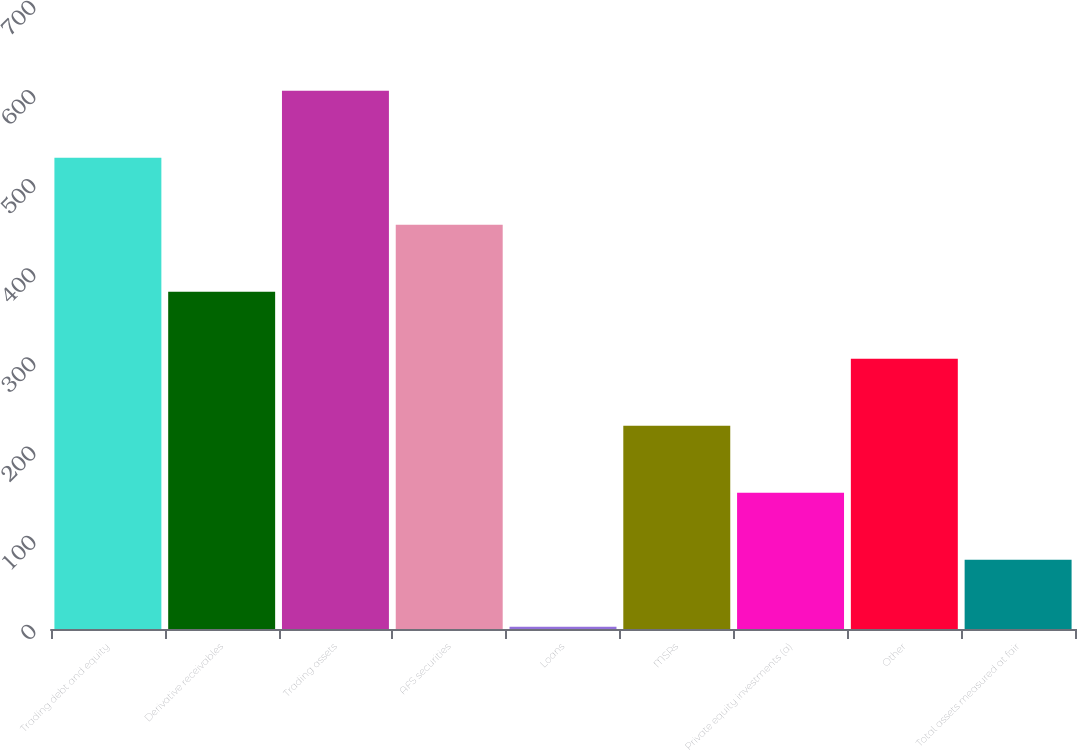Convert chart to OTSL. <chart><loc_0><loc_0><loc_500><loc_500><bar_chart><fcel>Trading debt and equity<fcel>Derivative receivables<fcel>Trading assets<fcel>AFS securities<fcel>Loans<fcel>MSRs<fcel>Private equity investments (a)<fcel>Other<fcel>Total assets measured at fair<nl><fcel>528.72<fcel>378.4<fcel>603.88<fcel>453.56<fcel>2.6<fcel>228.08<fcel>152.92<fcel>303.24<fcel>77.76<nl></chart> 